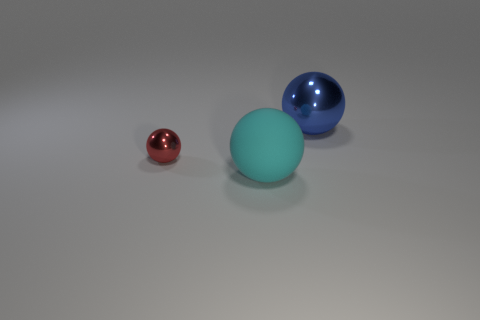Are there any cylinders?
Provide a succinct answer. No. There is a big object behind the tiny red metallic sphere; what is its material?
Provide a short and direct response. Metal. How many tiny things are either red things or matte objects?
Offer a terse response. 1. The small thing has what color?
Your response must be concise. Red. There is a shiny thing left of the large metallic sphere; is there a ball that is behind it?
Provide a succinct answer. Yes. Are there fewer big cyan things right of the rubber sphere than tiny yellow spheres?
Your response must be concise. No. Does the ball in front of the small shiny thing have the same material as the tiny object?
Give a very brief answer. No. The big thing that is the same material as the tiny object is what color?
Your answer should be very brief. Blue. Is the number of red things to the right of the big cyan ball less than the number of red metallic things that are in front of the large blue ball?
Provide a short and direct response. Yes. There is a thing that is in front of the small red ball; is it the same color as the object behind the tiny red shiny object?
Your answer should be compact. No. 